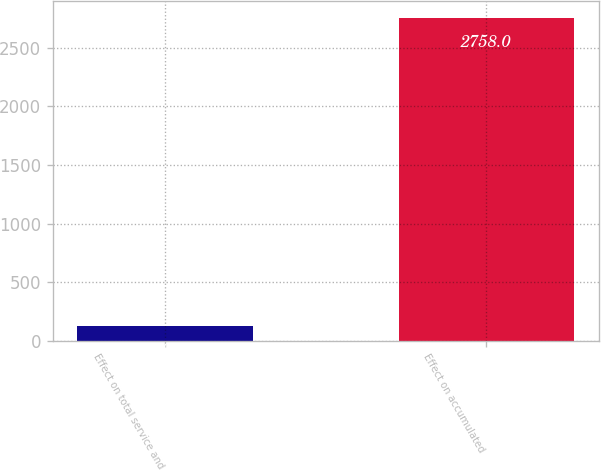Convert chart to OTSL. <chart><loc_0><loc_0><loc_500><loc_500><bar_chart><fcel>Effect on total service and<fcel>Effect on accumulated<nl><fcel>129<fcel>2758<nl></chart> 